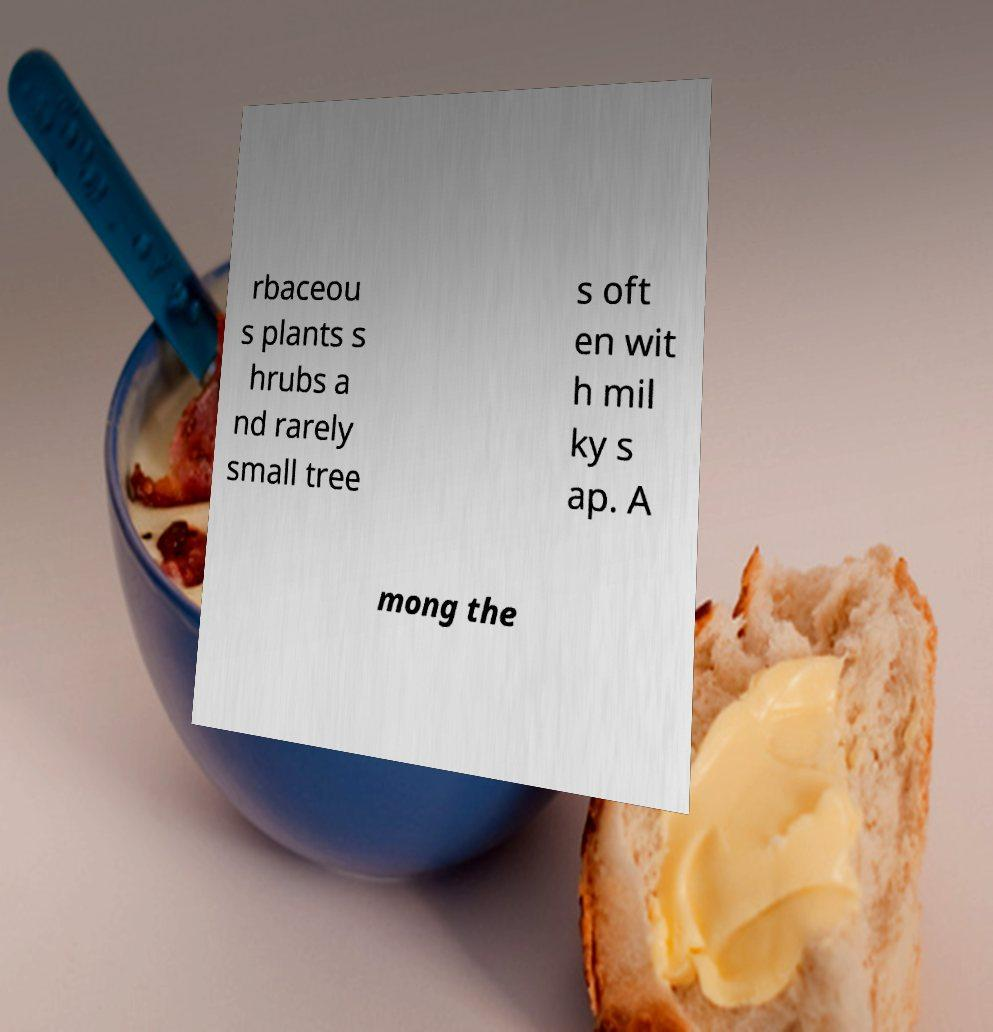What messages or text are displayed in this image? I need them in a readable, typed format. rbaceou s plants s hrubs a nd rarely small tree s oft en wit h mil ky s ap. A mong the 